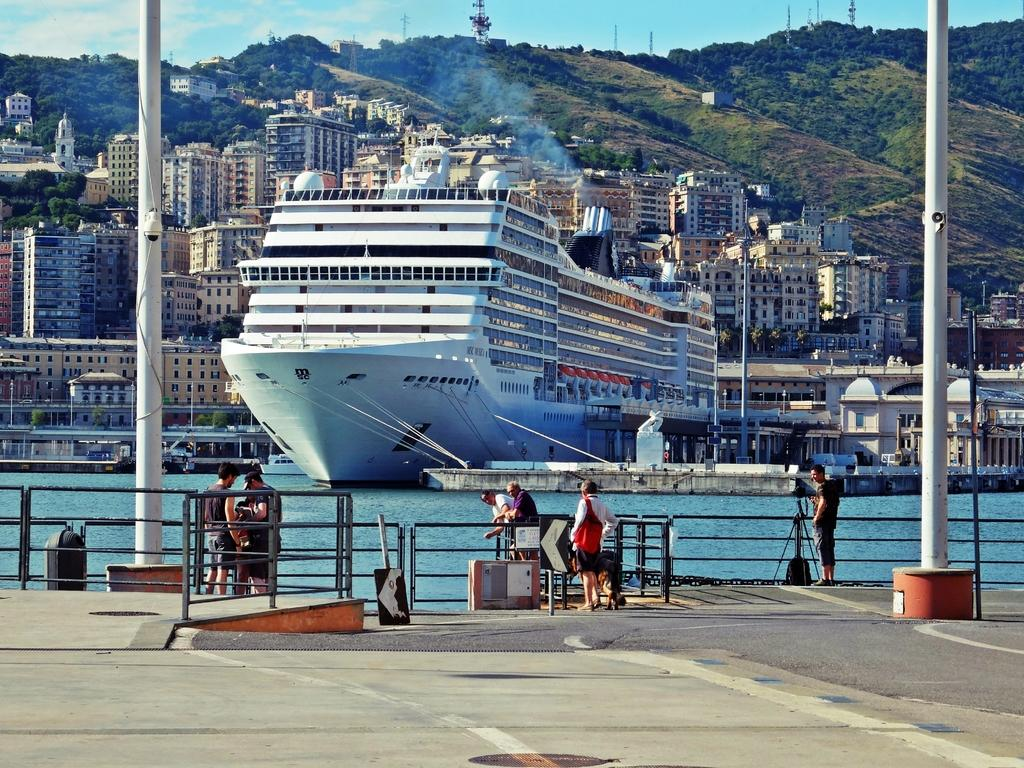What can be seen in the image? There are persons standing in the image, along with railings. What is visible in the background of the image? In the background, there is water with a ship, buildings, trees, and poles. Can you describe the water in the background? The water in the background has a ship on it. What else is present in the background of the image? There are buildings and trees in the background. Are there any other structures visible in the background? Yes, there are poles in the background. How many jellyfish can be seen swimming near the persons in the image? There are no jellyfish present in the image; it features persons standing near railings with a background of water, a ship, buildings, trees, and poles. 